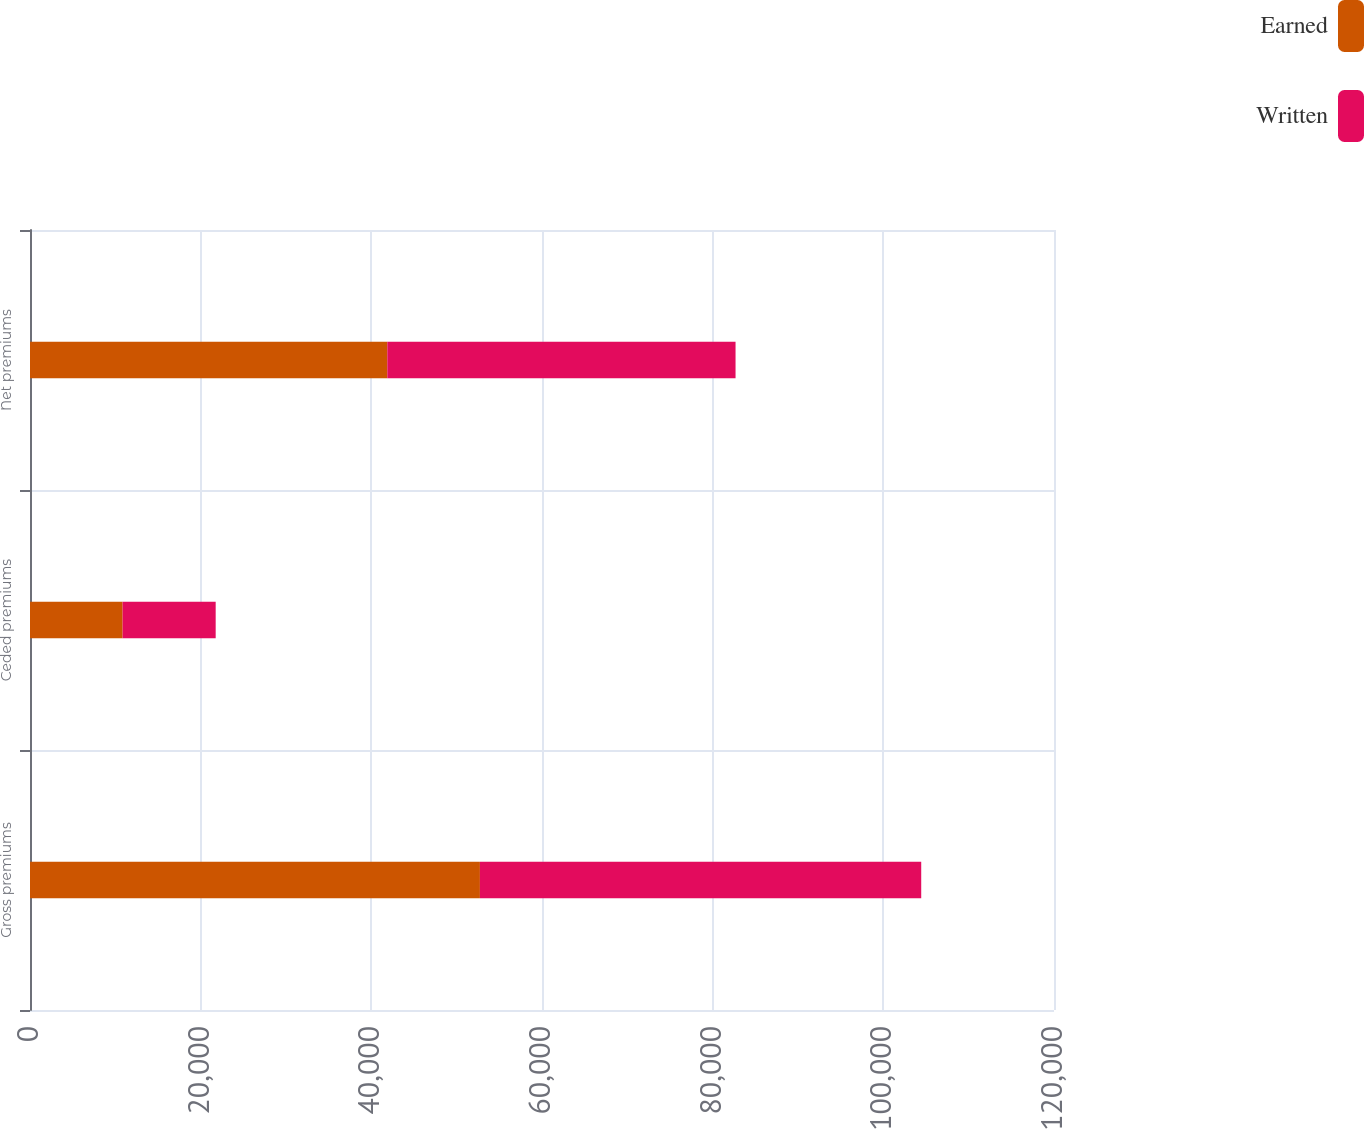Convert chart. <chart><loc_0><loc_0><loc_500><loc_500><stacked_bar_chart><ecel><fcel>Gross premiums<fcel>Ceded premiums<fcel>Net premiums<nl><fcel>Earned<fcel>52725<fcel>10853<fcel>41872<nl><fcel>Written<fcel>51715<fcel>10906<fcel>40809<nl></chart> 